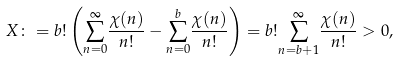Convert formula to latex. <formula><loc_0><loc_0><loc_500><loc_500>X \colon = b ! \left ( \overset { \infty } { \sum _ { n = 0 } } \frac { \chi ( n ) } { n ! } - \overset { b } { \sum _ { n = 0 } } \frac { \chi ( n ) } { n ! } \right ) = b ! \overset { \infty } { \sum _ { n = b + 1 } } \frac { \chi ( n ) } { n ! } > 0 ,</formula> 